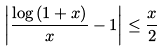Convert formula to latex. <formula><loc_0><loc_0><loc_500><loc_500>\left | \frac { \log { ( 1 + x ) } } { x } - 1 \right | \leq \frac { x } { 2 }</formula> 